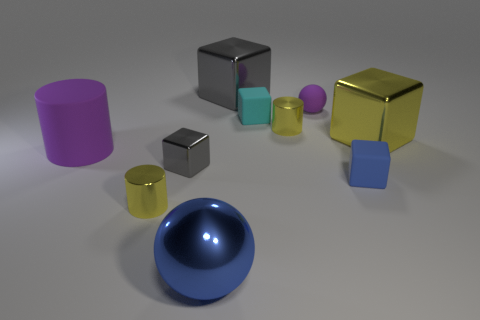Are there more metallic blocks in front of the big yellow object than tiny matte things that are in front of the purple sphere?
Provide a succinct answer. No. What number of other things are the same size as the blue shiny thing?
Your response must be concise. 3. There is a purple thing that is in front of the small object that is behind the tiny cyan object; how big is it?
Your answer should be very brief. Large. What number of tiny objects are metallic spheres or gray cubes?
Offer a very short reply. 1. How big is the yellow metal cube behind the large metal object that is in front of the small yellow cylinder that is in front of the purple matte cylinder?
Make the answer very short. Large. What material is the yellow thing that is right of the small yellow metallic cylinder that is right of the small object that is to the left of the tiny gray shiny block made of?
Your response must be concise. Metal. Is the shape of the small gray metallic object the same as the small blue matte object?
Keep it short and to the point. Yes. What number of big things are right of the blue shiny sphere and left of the large yellow block?
Provide a short and direct response. 1. There is a thing that is in front of the small yellow metal cylinder in front of the small gray shiny thing; what color is it?
Your answer should be very brief. Blue. Are there an equal number of small yellow things that are on the right side of the tiny purple thing and small cyan cylinders?
Provide a short and direct response. Yes. 